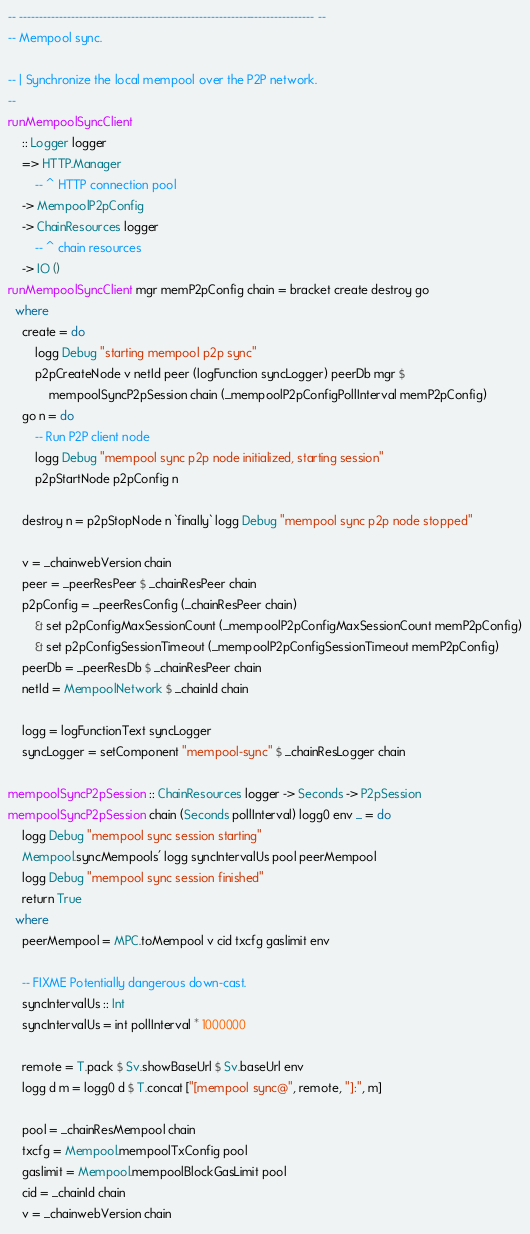<code> <loc_0><loc_0><loc_500><loc_500><_Haskell_>-- -------------------------------------------------------------------------- --
-- Mempool sync.

-- | Synchronize the local mempool over the P2P network.
--
runMempoolSyncClient
    :: Logger logger
    => HTTP.Manager
        -- ^ HTTP connection pool
    -> MempoolP2pConfig
    -> ChainResources logger
        -- ^ chain resources
    -> IO ()
runMempoolSyncClient mgr memP2pConfig chain = bracket create destroy go
  where
    create = do
        logg Debug "starting mempool p2p sync"
        p2pCreateNode v netId peer (logFunction syncLogger) peerDb mgr $
            mempoolSyncP2pSession chain (_mempoolP2pConfigPollInterval memP2pConfig)
    go n = do
        -- Run P2P client node
        logg Debug "mempool sync p2p node initialized, starting session"
        p2pStartNode p2pConfig n

    destroy n = p2pStopNode n `finally` logg Debug "mempool sync p2p node stopped"

    v = _chainwebVersion chain
    peer = _peerResPeer $ _chainResPeer chain
    p2pConfig = _peerResConfig (_chainResPeer chain)
        & set p2pConfigMaxSessionCount (_mempoolP2pConfigMaxSessionCount memP2pConfig)
        & set p2pConfigSessionTimeout (_mempoolP2pConfigSessionTimeout memP2pConfig)
    peerDb = _peerResDb $ _chainResPeer chain
    netId = MempoolNetwork $ _chainId chain

    logg = logFunctionText syncLogger
    syncLogger = setComponent "mempool-sync" $ _chainResLogger chain

mempoolSyncP2pSession :: ChainResources logger -> Seconds -> P2pSession
mempoolSyncP2pSession chain (Seconds pollInterval) logg0 env _ = do
    logg Debug "mempool sync session starting"
    Mempool.syncMempools' logg syncIntervalUs pool peerMempool
    logg Debug "mempool sync session finished"
    return True
  where
    peerMempool = MPC.toMempool v cid txcfg gaslimit env

    -- FIXME Potentially dangerous down-cast.
    syncIntervalUs :: Int
    syncIntervalUs = int pollInterval * 1000000

    remote = T.pack $ Sv.showBaseUrl $ Sv.baseUrl env
    logg d m = logg0 d $ T.concat ["[mempool sync@", remote, "]:", m]

    pool = _chainResMempool chain
    txcfg = Mempool.mempoolTxConfig pool
    gaslimit = Mempool.mempoolBlockGasLimit pool
    cid = _chainId chain
    v = _chainwebVersion chain
</code> 